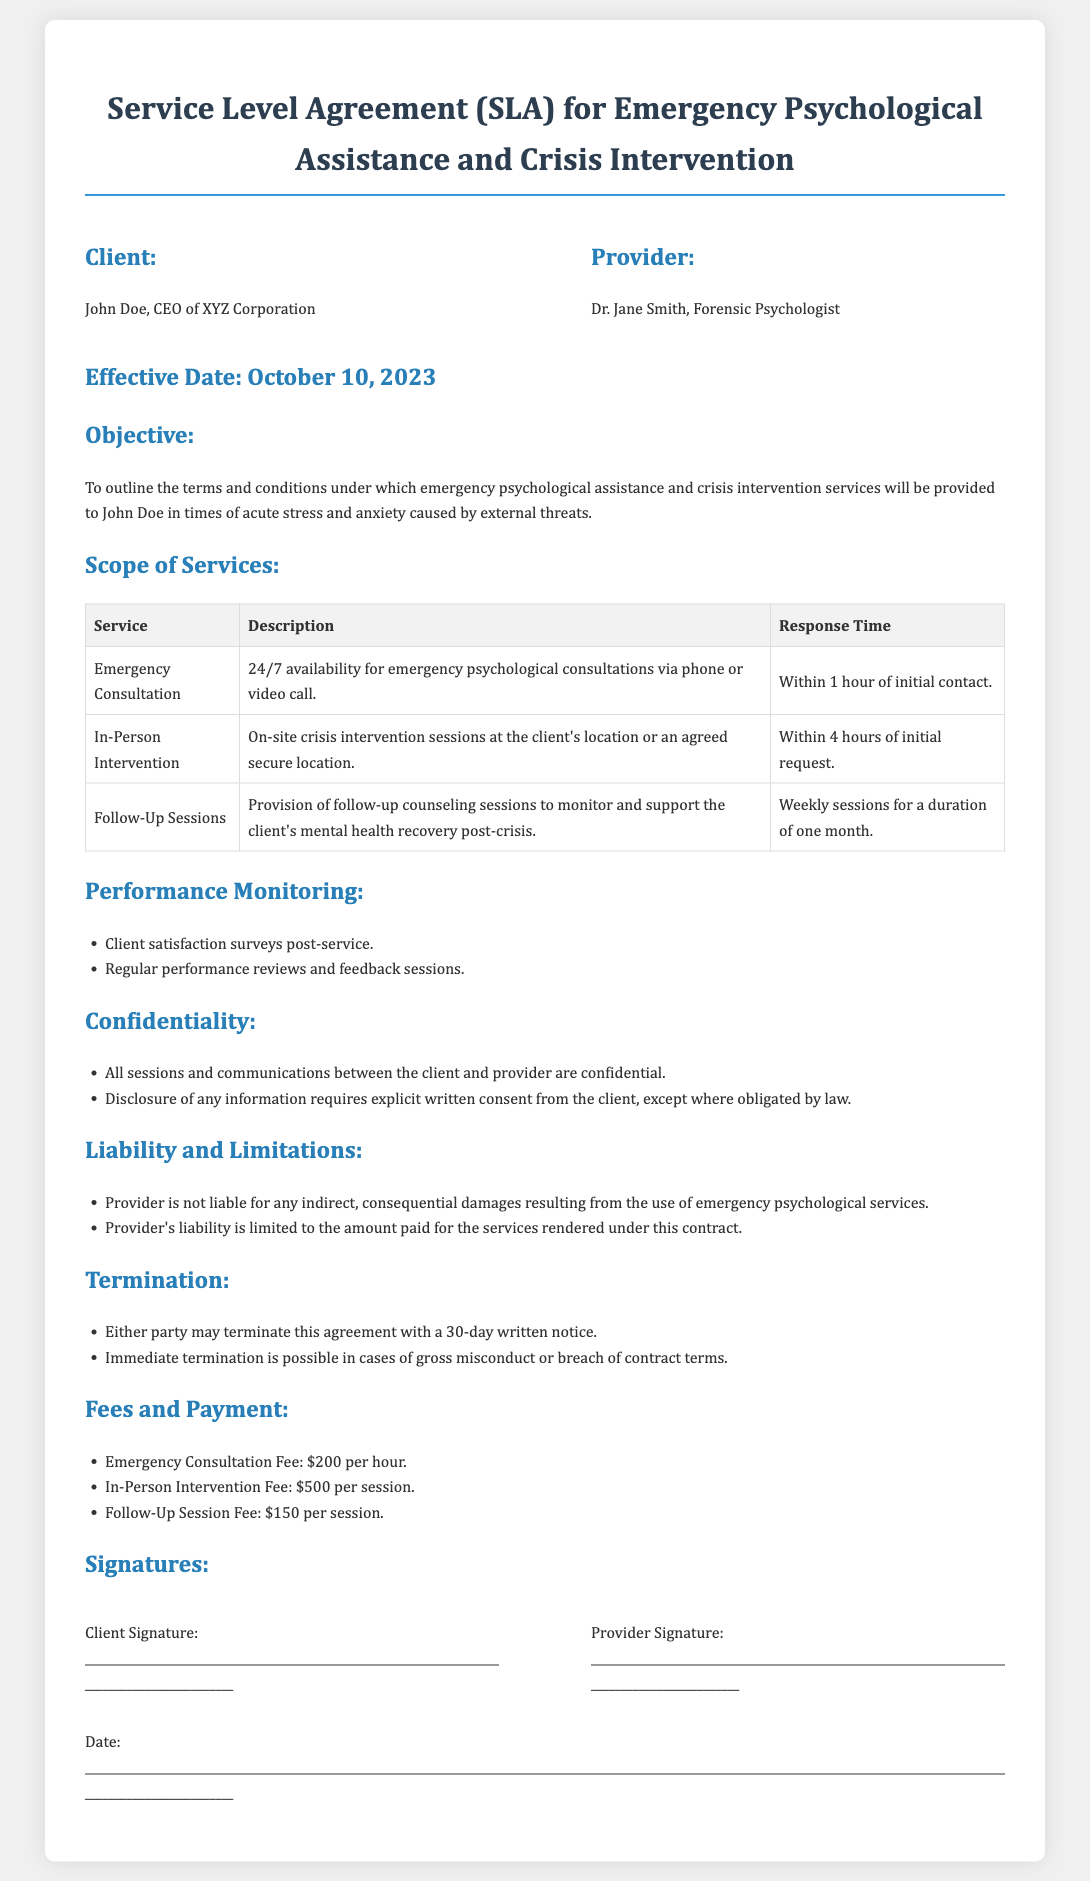What is the name of the client? The client's name, as stated in the document, is John Doe.
Answer: John Doe Who is the provider of the services? The provider, indicated in the document, is Dr. Jane Smith.
Answer: Dr. Jane Smith What is the effective date of the agreement? The agreement's effective date is mentioned clearly in the document as October 10, 2023.
Answer: October 10, 2023 What is the fee for the Emergency Consultation? The fee for the Emergency Consultation is specified in the document as $200 per hour.
Answer: $200 per hour How long should follow-up sessions be conducted? The document states follow-up sessions should be conducted weekly for a duration of one month.
Answer: One month What response time is stipulated for In-Person Intervention? The stipulated response time for In-Person Intervention, according to the document, is within 4 hours of the initial request.
Answer: Within 4 hours What does the confidentiality clause emphasize? The confidentiality clause emphasizes that all sessions and communications are confidential, with certain exceptions.
Answer: Confidentiality How can the agreement be terminated? The agreement can be terminated by either party with a 30-day written notice or immediately in case of gross misconduct.
Answer: 30-day written notice What is the liability limitation stated in the document? The document states that the provider's liability is limited to the amount paid for the services rendered.
Answer: Amount paid 